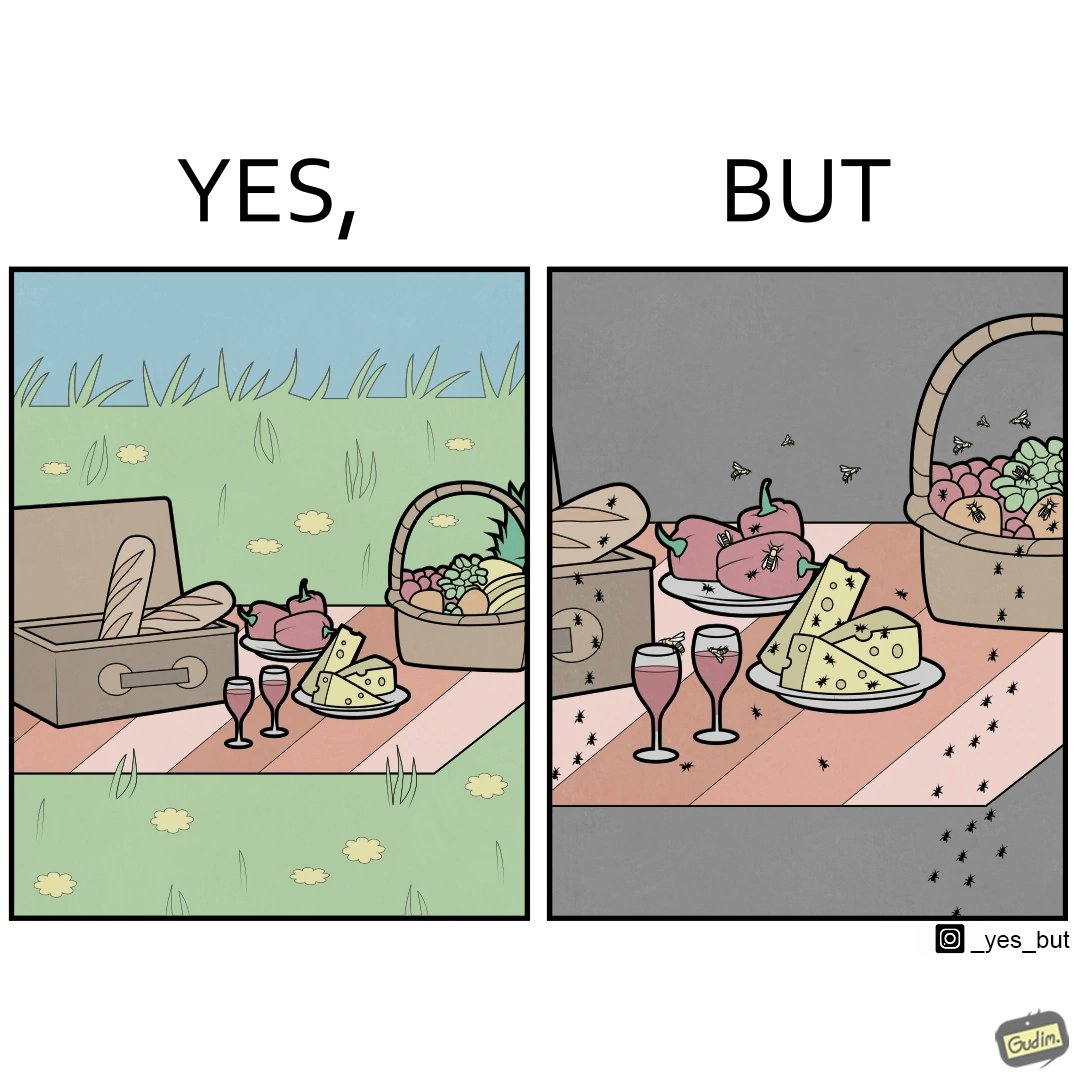Provide a description of this image. The Picture shows that although we enjoy food in garden but there are some consequences of eating food in garden. Many bugs and bees are attracted towards our food and make our food sometimes non-eatable. 